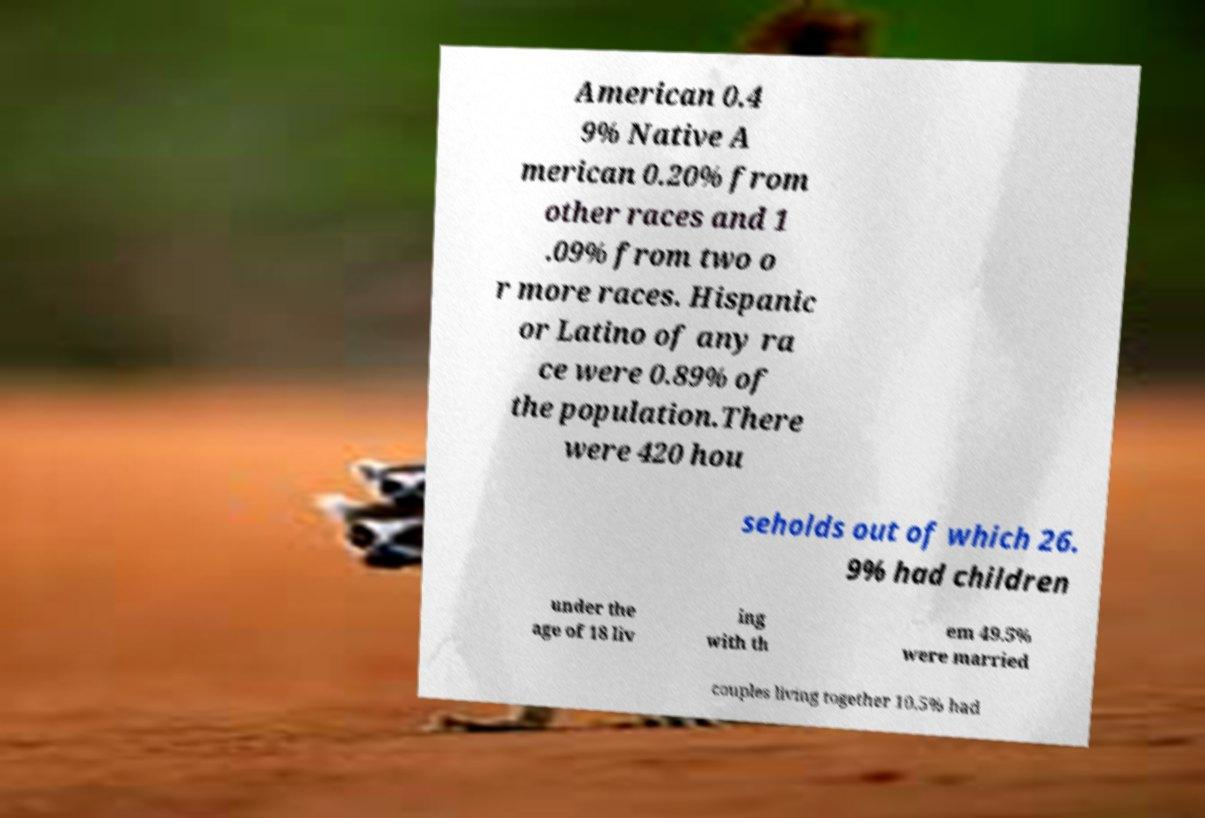Please read and relay the text visible in this image. What does it say? American 0.4 9% Native A merican 0.20% from other races and 1 .09% from two o r more races. Hispanic or Latino of any ra ce were 0.89% of the population.There were 420 hou seholds out of which 26. 9% had children under the age of 18 liv ing with th em 49.5% were married couples living together 10.5% had 